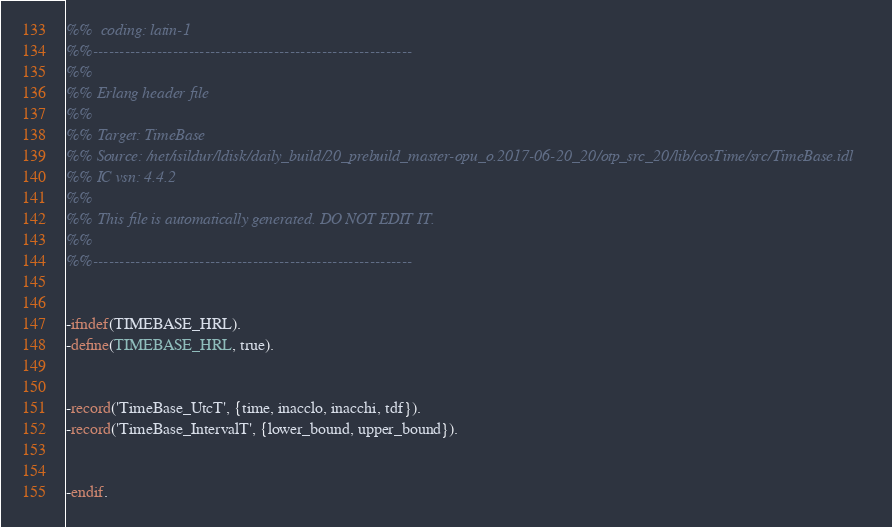Convert code to text. <code><loc_0><loc_0><loc_500><loc_500><_Erlang_>%%  coding: latin-1
%%------------------------------------------------------------
%%
%% Erlang header file
%% 
%% Target: TimeBase
%% Source: /net/isildur/ldisk/daily_build/20_prebuild_master-opu_o.2017-06-20_20/otp_src_20/lib/cosTime/src/TimeBase.idl
%% IC vsn: 4.4.2
%% 
%% This file is automatically generated. DO NOT EDIT IT.
%%
%%------------------------------------------------------------


-ifndef(TIMEBASE_HRL).
-define(TIMEBASE_HRL, true).


-record('TimeBase_UtcT', {time, inacclo, inacchi, tdf}).
-record('TimeBase_IntervalT', {lower_bound, upper_bound}).


-endif.


</code> 